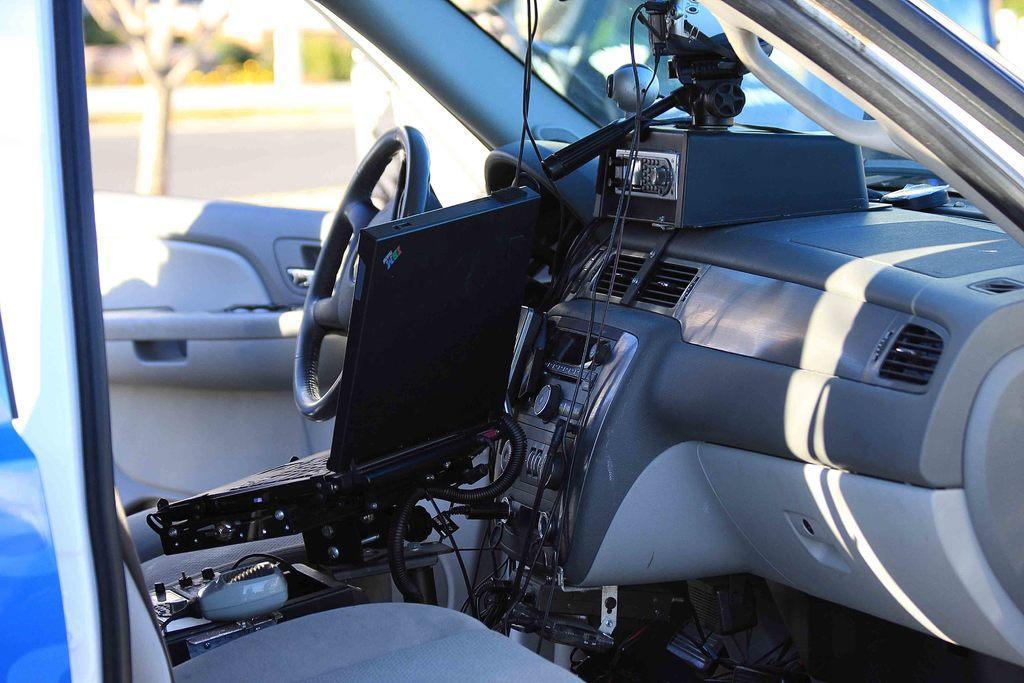Describe this image in one or two sentences. In this image I can see the inside view of the vehicle. In the vehicle I can see the steering, music system, seats and many black color objects. In the background I can see many trees. 